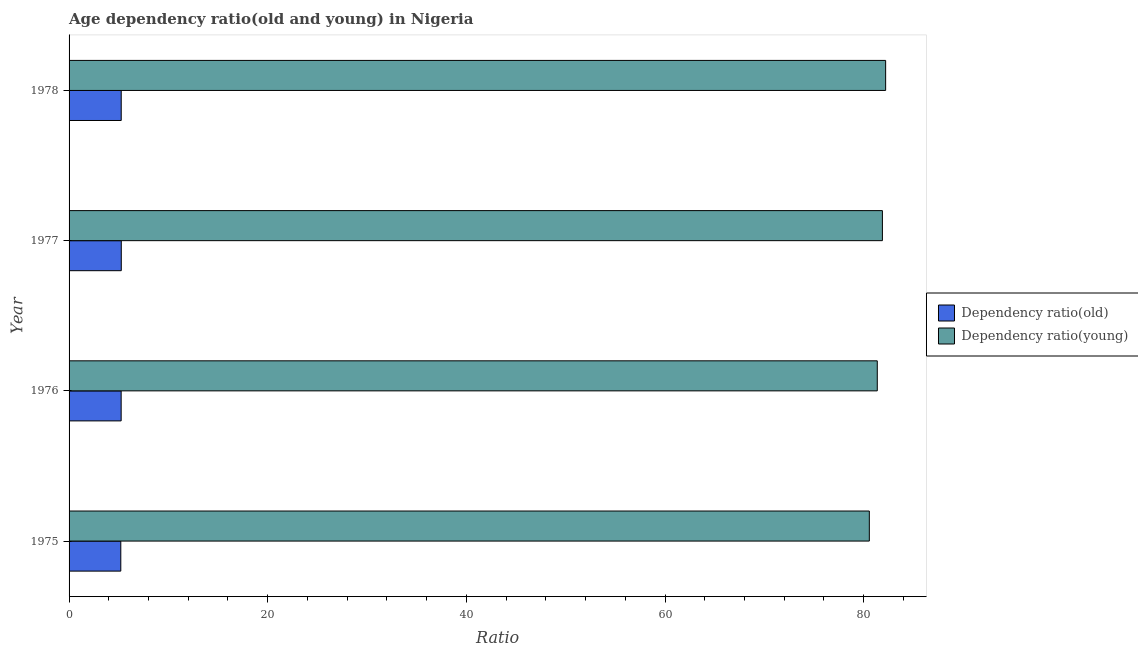How many different coloured bars are there?
Make the answer very short. 2. How many groups of bars are there?
Your answer should be compact. 4. How many bars are there on the 4th tick from the top?
Your answer should be very brief. 2. What is the label of the 3rd group of bars from the top?
Provide a short and direct response. 1976. What is the age dependency ratio(old) in 1978?
Make the answer very short. 5.25. Across all years, what is the maximum age dependency ratio(young)?
Offer a very short reply. 82.21. Across all years, what is the minimum age dependency ratio(young)?
Give a very brief answer. 80.57. In which year was the age dependency ratio(old) minimum?
Offer a terse response. 1975. What is the total age dependency ratio(old) in the graph?
Make the answer very short. 20.96. What is the difference between the age dependency ratio(young) in 1975 and that in 1977?
Ensure brevity in your answer.  -1.32. What is the difference between the age dependency ratio(young) in 1976 and the age dependency ratio(old) in 1978?
Provide a succinct answer. 76.12. What is the average age dependency ratio(old) per year?
Ensure brevity in your answer.  5.24. In the year 1978, what is the difference between the age dependency ratio(old) and age dependency ratio(young)?
Offer a terse response. -76.96. In how many years, is the age dependency ratio(old) greater than 4 ?
Offer a very short reply. 4. What is the ratio of the age dependency ratio(old) in 1977 to that in 1978?
Provide a short and direct response. 1. Is the difference between the age dependency ratio(old) in 1976 and 1977 greater than the difference between the age dependency ratio(young) in 1976 and 1977?
Your answer should be compact. Yes. What is the difference between the highest and the second highest age dependency ratio(old)?
Your answer should be compact. 0.01. What is the difference between the highest and the lowest age dependency ratio(old)?
Offer a very short reply. 0.05. What does the 1st bar from the top in 1978 represents?
Ensure brevity in your answer.  Dependency ratio(young). What does the 2nd bar from the bottom in 1976 represents?
Provide a short and direct response. Dependency ratio(young). What is the difference between two consecutive major ticks on the X-axis?
Offer a very short reply. 20. Are the values on the major ticks of X-axis written in scientific E-notation?
Provide a short and direct response. No. Does the graph contain any zero values?
Offer a terse response. No. Does the graph contain grids?
Offer a terse response. No. What is the title of the graph?
Give a very brief answer. Age dependency ratio(old and young) in Nigeria. Does "Commercial bank branches" appear as one of the legend labels in the graph?
Offer a terse response. No. What is the label or title of the X-axis?
Your answer should be compact. Ratio. What is the label or title of the Y-axis?
Provide a short and direct response. Year. What is the Ratio of Dependency ratio(old) in 1975?
Ensure brevity in your answer.  5.21. What is the Ratio in Dependency ratio(young) in 1975?
Your answer should be very brief. 80.57. What is the Ratio in Dependency ratio(old) in 1976?
Your response must be concise. 5.24. What is the Ratio in Dependency ratio(young) in 1976?
Ensure brevity in your answer.  81.37. What is the Ratio of Dependency ratio(old) in 1977?
Ensure brevity in your answer.  5.26. What is the Ratio in Dependency ratio(young) in 1977?
Give a very brief answer. 81.89. What is the Ratio of Dependency ratio(old) in 1978?
Give a very brief answer. 5.25. What is the Ratio of Dependency ratio(young) in 1978?
Your answer should be very brief. 82.21. Across all years, what is the maximum Ratio in Dependency ratio(old)?
Keep it short and to the point. 5.26. Across all years, what is the maximum Ratio of Dependency ratio(young)?
Keep it short and to the point. 82.21. Across all years, what is the minimum Ratio in Dependency ratio(old)?
Your response must be concise. 5.21. Across all years, what is the minimum Ratio in Dependency ratio(young)?
Your response must be concise. 80.57. What is the total Ratio of Dependency ratio(old) in the graph?
Offer a terse response. 20.96. What is the total Ratio in Dependency ratio(young) in the graph?
Your answer should be very brief. 326.04. What is the difference between the Ratio in Dependency ratio(old) in 1975 and that in 1976?
Ensure brevity in your answer.  -0.04. What is the difference between the Ratio in Dependency ratio(young) in 1975 and that in 1976?
Make the answer very short. -0.8. What is the difference between the Ratio in Dependency ratio(old) in 1975 and that in 1977?
Make the answer very short. -0.05. What is the difference between the Ratio in Dependency ratio(young) in 1975 and that in 1977?
Your answer should be compact. -1.32. What is the difference between the Ratio of Dependency ratio(old) in 1975 and that in 1978?
Offer a very short reply. -0.04. What is the difference between the Ratio in Dependency ratio(young) in 1975 and that in 1978?
Ensure brevity in your answer.  -1.64. What is the difference between the Ratio of Dependency ratio(old) in 1976 and that in 1977?
Keep it short and to the point. -0.01. What is the difference between the Ratio of Dependency ratio(young) in 1976 and that in 1977?
Keep it short and to the point. -0.52. What is the difference between the Ratio in Dependency ratio(old) in 1976 and that in 1978?
Offer a very short reply. -0.01. What is the difference between the Ratio of Dependency ratio(young) in 1976 and that in 1978?
Make the answer very short. -0.84. What is the difference between the Ratio in Dependency ratio(old) in 1977 and that in 1978?
Make the answer very short. 0.01. What is the difference between the Ratio of Dependency ratio(young) in 1977 and that in 1978?
Offer a terse response. -0.33. What is the difference between the Ratio in Dependency ratio(old) in 1975 and the Ratio in Dependency ratio(young) in 1976?
Your response must be concise. -76.16. What is the difference between the Ratio in Dependency ratio(old) in 1975 and the Ratio in Dependency ratio(young) in 1977?
Offer a very short reply. -76.68. What is the difference between the Ratio in Dependency ratio(old) in 1975 and the Ratio in Dependency ratio(young) in 1978?
Your response must be concise. -77.01. What is the difference between the Ratio of Dependency ratio(old) in 1976 and the Ratio of Dependency ratio(young) in 1977?
Make the answer very short. -76.64. What is the difference between the Ratio in Dependency ratio(old) in 1976 and the Ratio in Dependency ratio(young) in 1978?
Ensure brevity in your answer.  -76.97. What is the difference between the Ratio of Dependency ratio(old) in 1977 and the Ratio of Dependency ratio(young) in 1978?
Offer a terse response. -76.96. What is the average Ratio of Dependency ratio(old) per year?
Provide a succinct answer. 5.24. What is the average Ratio in Dependency ratio(young) per year?
Your answer should be very brief. 81.51. In the year 1975, what is the difference between the Ratio in Dependency ratio(old) and Ratio in Dependency ratio(young)?
Your answer should be very brief. -75.36. In the year 1976, what is the difference between the Ratio in Dependency ratio(old) and Ratio in Dependency ratio(young)?
Your response must be concise. -76.13. In the year 1977, what is the difference between the Ratio in Dependency ratio(old) and Ratio in Dependency ratio(young)?
Keep it short and to the point. -76.63. In the year 1978, what is the difference between the Ratio in Dependency ratio(old) and Ratio in Dependency ratio(young)?
Your response must be concise. -76.96. What is the ratio of the Ratio in Dependency ratio(old) in 1975 to that in 1976?
Make the answer very short. 0.99. What is the ratio of the Ratio of Dependency ratio(young) in 1975 to that in 1976?
Your answer should be compact. 0.99. What is the ratio of the Ratio in Dependency ratio(old) in 1975 to that in 1977?
Your answer should be compact. 0.99. What is the ratio of the Ratio of Dependency ratio(young) in 1975 to that in 1977?
Give a very brief answer. 0.98. What is the ratio of the Ratio of Dependency ratio(young) in 1975 to that in 1978?
Keep it short and to the point. 0.98. What is the ratio of the Ratio of Dependency ratio(young) in 1976 to that in 1977?
Make the answer very short. 0.99. What is the ratio of the Ratio in Dependency ratio(young) in 1977 to that in 1978?
Provide a short and direct response. 1. What is the difference between the highest and the second highest Ratio in Dependency ratio(old)?
Give a very brief answer. 0.01. What is the difference between the highest and the second highest Ratio of Dependency ratio(young)?
Your response must be concise. 0.33. What is the difference between the highest and the lowest Ratio in Dependency ratio(old)?
Offer a terse response. 0.05. What is the difference between the highest and the lowest Ratio in Dependency ratio(young)?
Make the answer very short. 1.64. 